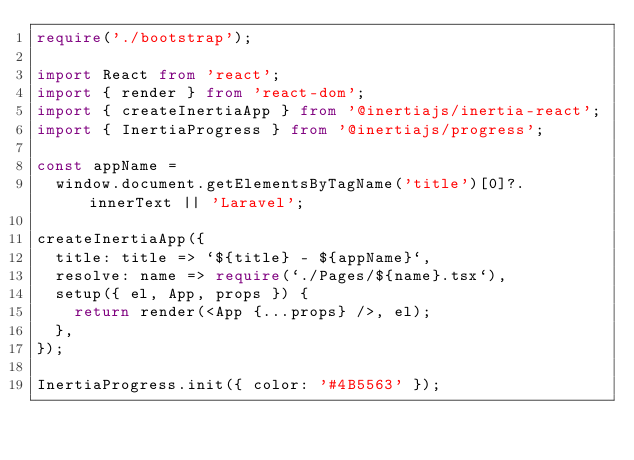<code> <loc_0><loc_0><loc_500><loc_500><_TypeScript_>require('./bootstrap');

import React from 'react';
import { render } from 'react-dom';
import { createInertiaApp } from '@inertiajs/inertia-react';
import { InertiaProgress } from '@inertiajs/progress';

const appName =
  window.document.getElementsByTagName('title')[0]?.innerText || 'Laravel';

createInertiaApp({
  title: title => `${title} - ${appName}`,
  resolve: name => require(`./Pages/${name}.tsx`),
  setup({ el, App, props }) {
    return render(<App {...props} />, el);
  },
});

InertiaProgress.init({ color: '#4B5563' });
</code> 